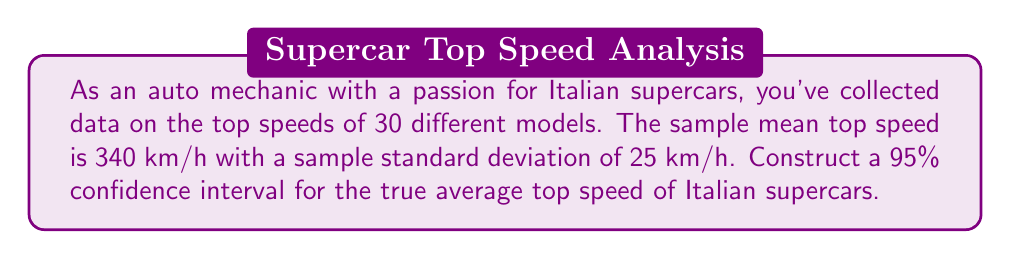Show me your answer to this math problem. Let's approach this step-by-step:

1) We're dealing with a confidence interval for a population mean with unknown population standard deviation. We'll use the t-distribution.

2) Given information:
   - Sample size: $n = 30$
   - Sample mean: $\bar{x} = 340$ km/h
   - Sample standard deviation: $s = 25$ km/h
   - Confidence level: 95%

3) The formula for the confidence interval is:

   $$\bar{x} \pm t_{\alpha/2, n-1} \cdot \frac{s}{\sqrt{n}}$$

4) For a 95% confidence interval, $\alpha = 0.05$, and $\alpha/2 = 0.025$

5) Degrees of freedom: $df = n - 1 = 30 - 1 = 29$

6) From the t-distribution table, $t_{0.025, 29} \approx 2.045$

7) Calculate the margin of error:

   $$\text{Margin of Error} = t_{0.025, 29} \cdot \frac{s}{\sqrt{n}} = 2.045 \cdot \frac{25}{\sqrt{30}} \approx 9.34$$

8) Now, we can construct the confidence interval:

   $$340 \pm 9.34$$

9) Therefore, the 95% confidence interval is (330.66, 349.34) km/h.
Answer: (330.66, 349.34) km/h 